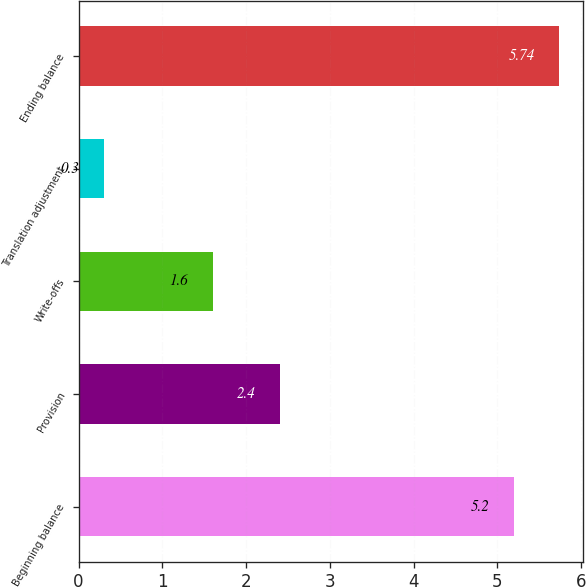Convert chart to OTSL. <chart><loc_0><loc_0><loc_500><loc_500><bar_chart><fcel>Beginning balance<fcel>Provision<fcel>Write-offs<fcel>Translation adjustment<fcel>Ending balance<nl><fcel>5.2<fcel>2.4<fcel>1.6<fcel>0.3<fcel>5.74<nl></chart> 